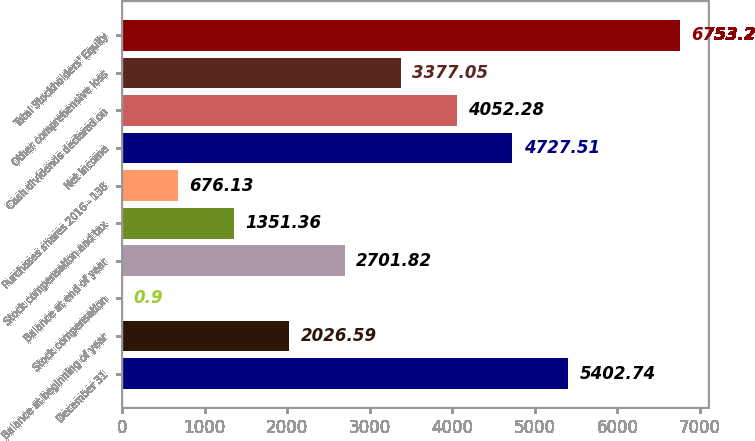<chart> <loc_0><loc_0><loc_500><loc_500><bar_chart><fcel>December 31<fcel>Balance at beginning of year<fcel>Stock compensation<fcel>Balance at end of year<fcel>Stock compensation and tax<fcel>Purchases shares 2016 - 138<fcel>Net income<fcel>Cash dividends declared on<fcel>Other comprehensive loss<fcel>Total Stockholders' Equity<nl><fcel>5402.74<fcel>2026.59<fcel>0.9<fcel>2701.82<fcel>1351.36<fcel>676.13<fcel>4727.51<fcel>4052.28<fcel>3377.05<fcel>6753.2<nl></chart> 